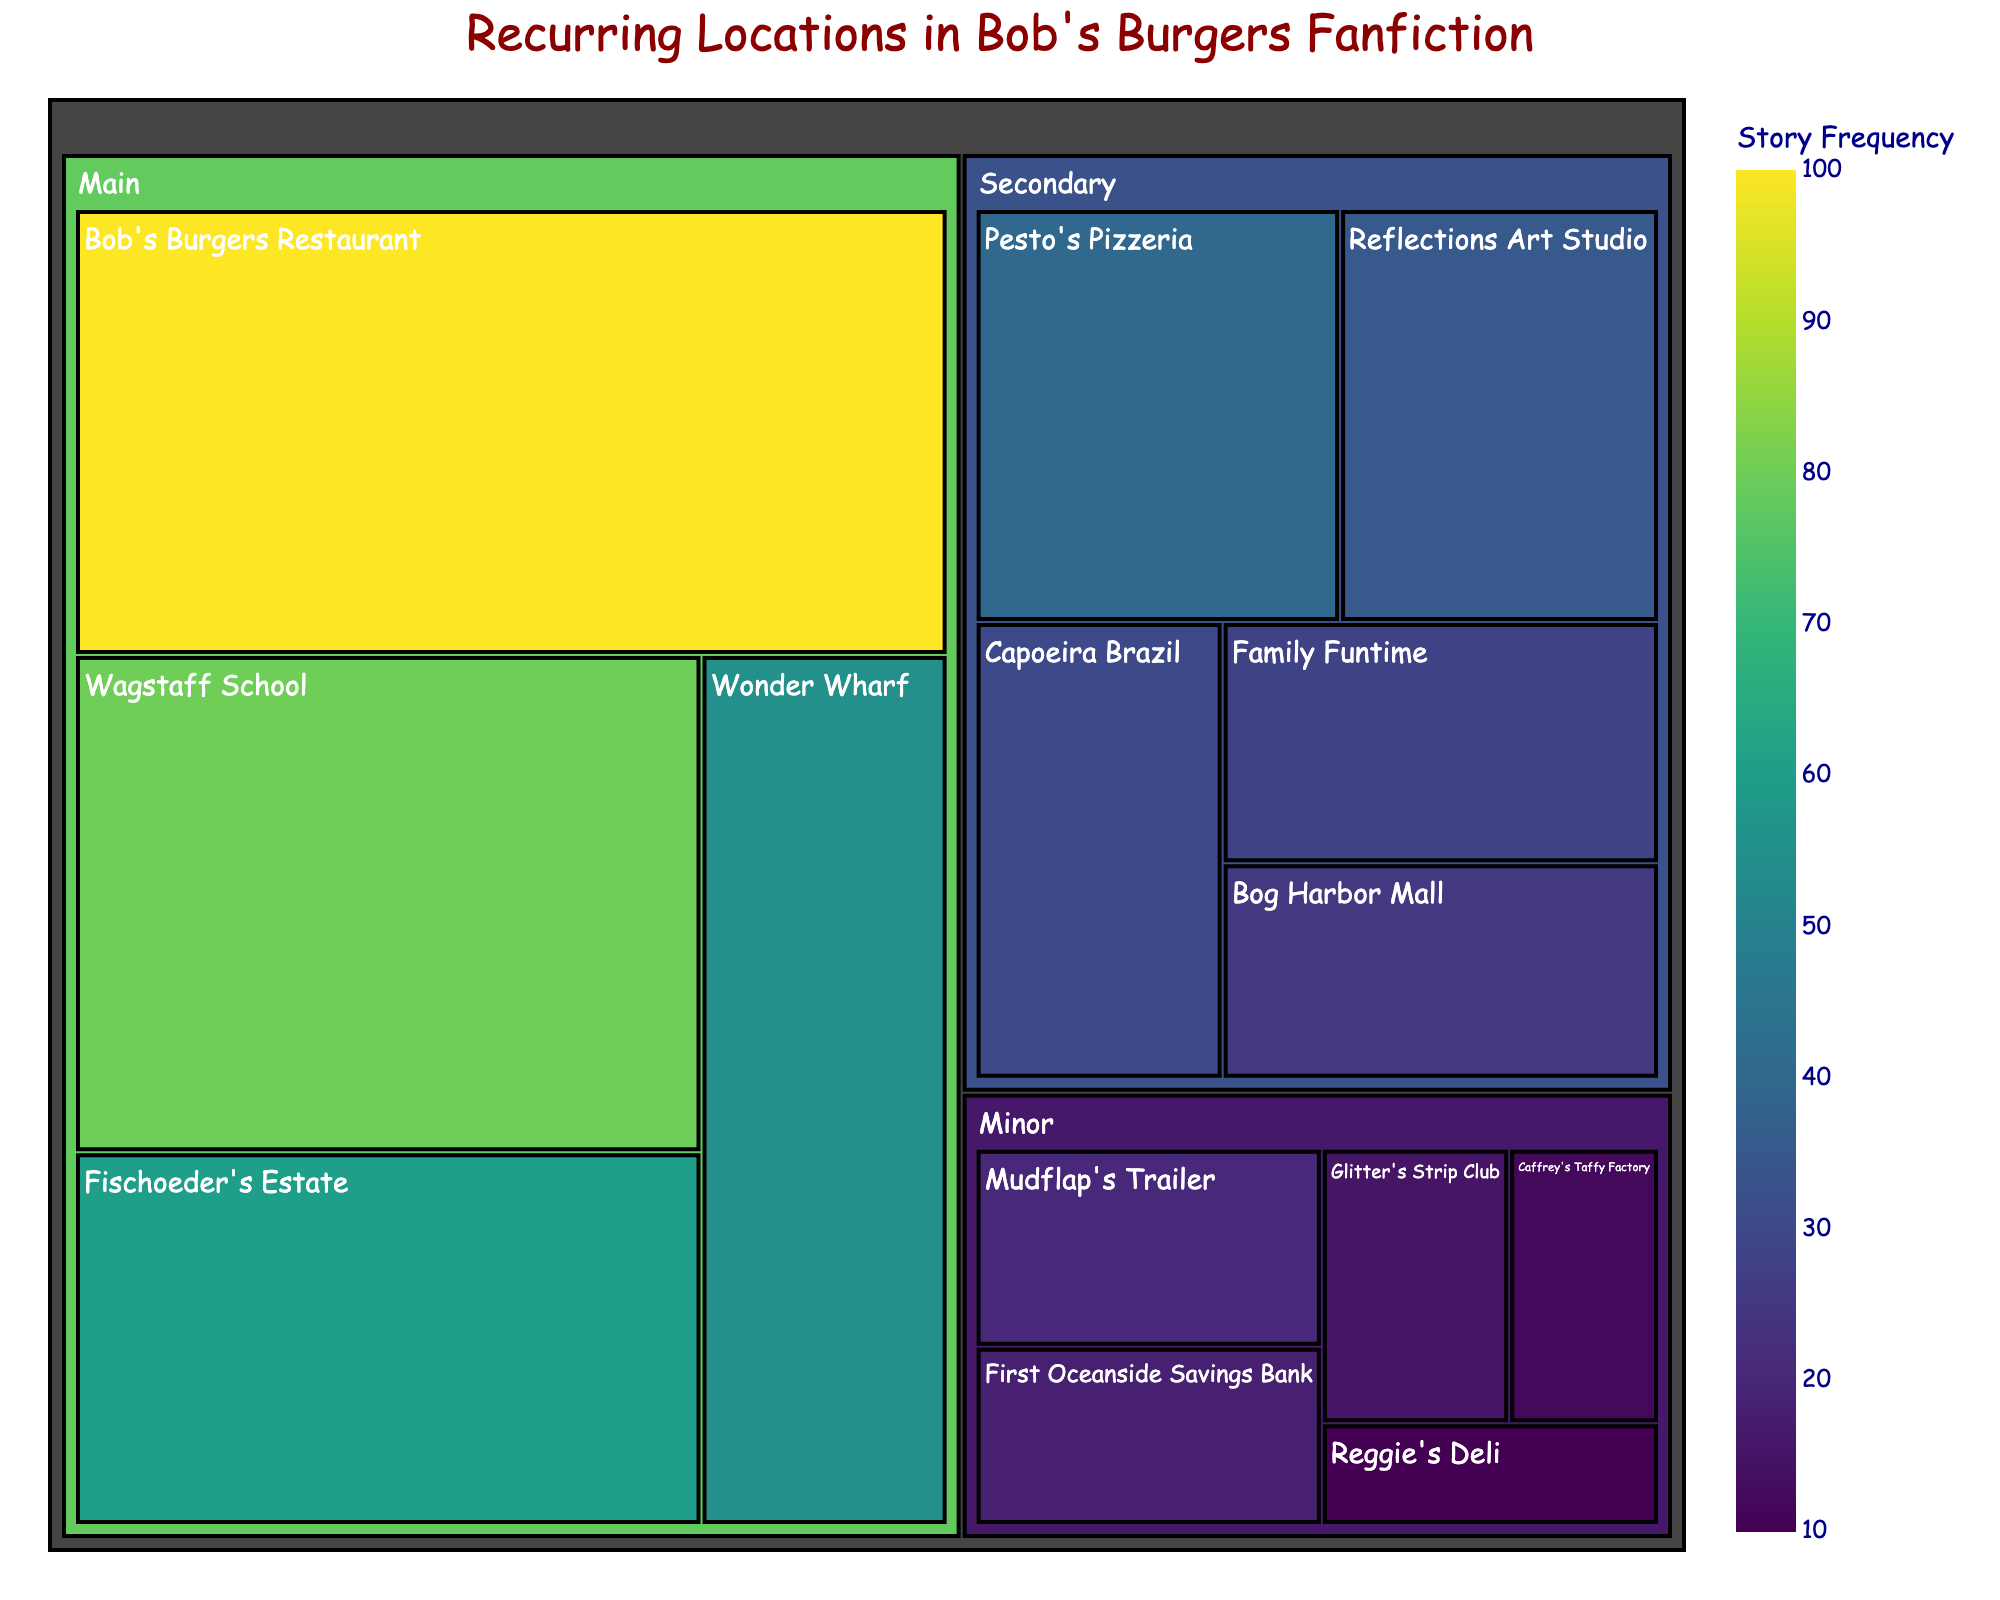what is the most frequent main location? The treemap shows frequencies of different locations, categorized into Main, Secondary, and Minor. Among the Main locations, Bob's Burgers Restaurant has the highest frequency since its section is the largest within the Main category.
Answer: Bob's Burgers Restaurant How many stories are set in the Secondary and Minor locations combined? The frequencies of Secondary locations add to 158, and Minor locations add to 75. Summing these gives the total number of stories for both categories: 158+75=233
Answer: 233 Which category has the highest number of locations, and how many? The treemap categorizes locations into Main, Secondary, and Minor. The category with the most locations is Secondary with six places: Pesto's Pizzeria, Reflections Art Studio, Capoeira Brazil, Family Funtime, Bog Harbor Mall, and Mudflap's Trailer.
Answer: Secondary, 6 What is the frequency difference between Wagstaff School and Fischoeder's Estate? The frequency for Wagstaff School is 80 and for Fischoeder's Estate is 60. The difference is 80-60=20
Answer: 20 Which Minor location has the smallest frequency, and what is that frequency? Looking at the Minor locations on the treemap, Reggie's Deli has the smallest frequency with a value of 10.
Answer: Reggie's Deli, 10 How do the sizes of the different categories compare overall? The treemap shows three categories. By visually comparing their sizes, the Main locations take up the most space, followed by Secondary and then Minor. Main is largest, then Secondary, Minor smallest
Answer: Main > Secondary > Minor What percentage of fanfiction stories are set in Wonder Wharf? Wonder Wharf's frequency is 55. The total number of stories across all locations is 486. The percentage is calculated as (55/486)*100 ≈ 11.32%
Answer: ~11.32% How does Fischoeder's Estate compare to the combined frequency of all Minor locations? Fischoeder's Estate has a frequency of 60. Combining all Minor locations gives 75. Comparing the two, 75 is greater than 60, meaning the Minor locations collectively have a higher frequency than Fischoeder's Estate.
Answer: Minor > Fischoeder's Estate 